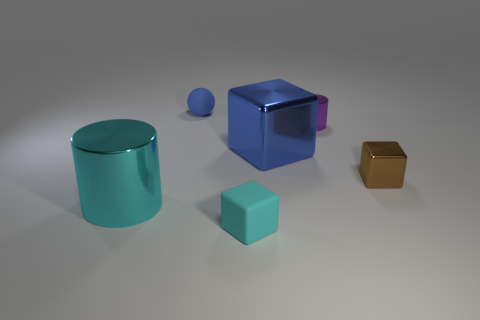Add 3 tiny red metal spheres. How many objects exist? 9 Subtract all cylinders. How many objects are left? 4 Add 6 blue things. How many blue things exist? 8 Subtract 0 red blocks. How many objects are left? 6 Subtract all large gray cubes. Subtract all cyan matte blocks. How many objects are left? 5 Add 6 big cylinders. How many big cylinders are left? 7 